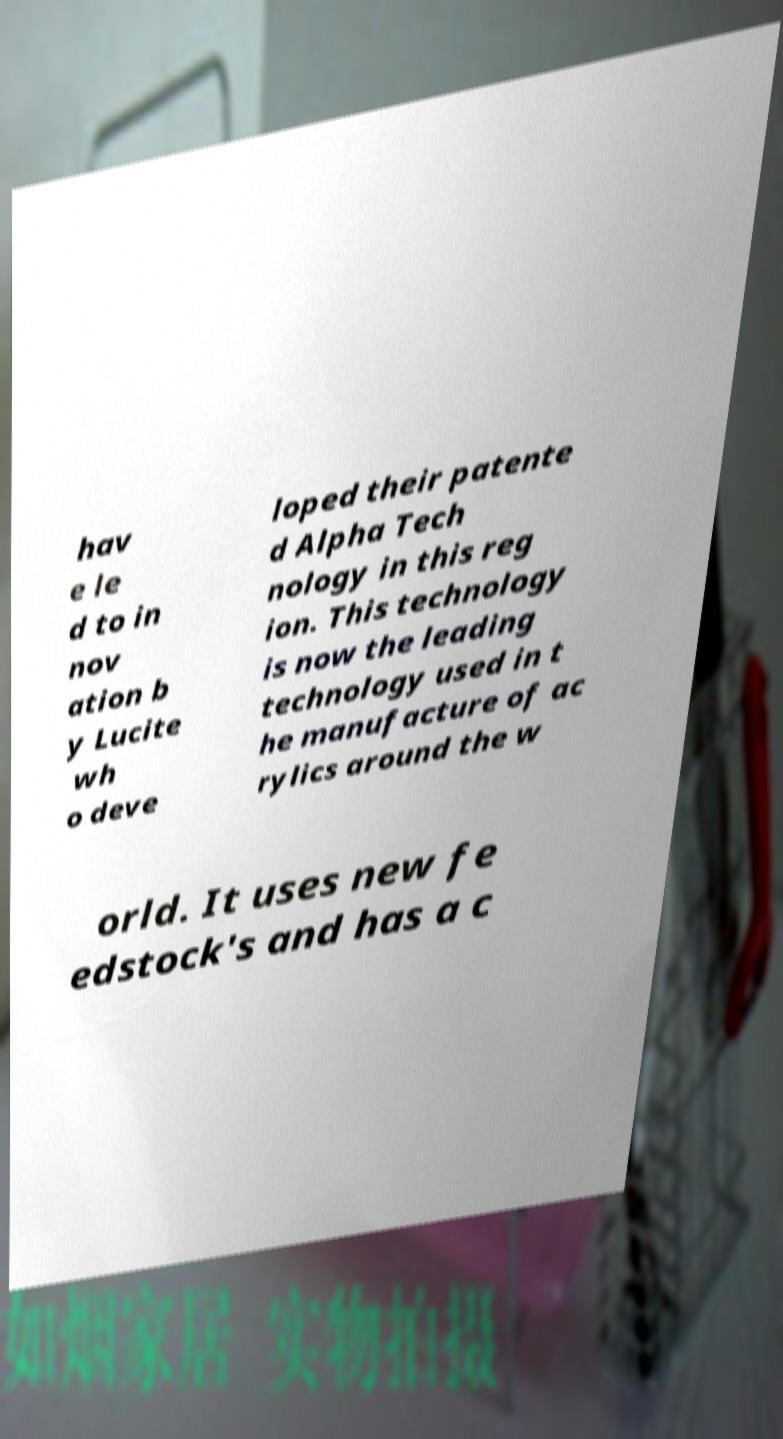Can you read and provide the text displayed in the image?This photo seems to have some interesting text. Can you extract and type it out for me? hav e le d to in nov ation b y Lucite wh o deve loped their patente d Alpha Tech nology in this reg ion. This technology is now the leading technology used in t he manufacture of ac rylics around the w orld. It uses new fe edstock's and has a c 